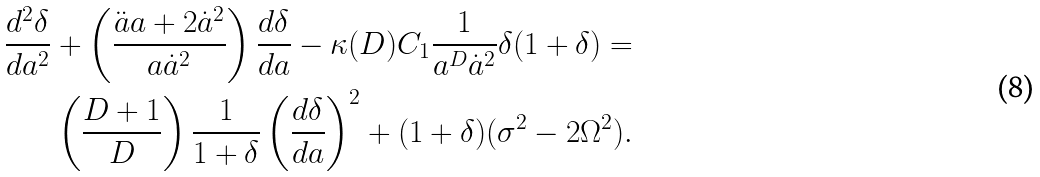<formula> <loc_0><loc_0><loc_500><loc_500>\frac { d ^ { 2 } \delta } { d a ^ { 2 } } + \left ( \frac { \ddot { a } a + 2 \dot { a } ^ { 2 } } { a \dot { a } ^ { 2 } } \right ) \frac { d \delta } { d a } - \kappa ( D ) C _ { 1 } \frac { 1 } { a ^ { D } \dot { a } ^ { 2 } } \delta ( 1 + \delta ) = \\ \left ( \frac { D + 1 } { D } \right ) \frac { 1 } { 1 + \delta } \left ( \frac { d \delta } { d a } \right ) ^ { 2 } + ( 1 + \delta ) ( \sigma ^ { 2 } - 2 \Omega ^ { 2 } ) .</formula> 